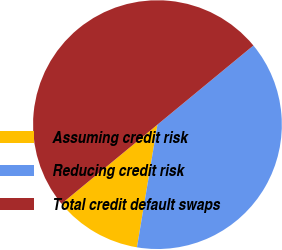Convert chart. <chart><loc_0><loc_0><loc_500><loc_500><pie_chart><fcel>Assuming credit risk<fcel>Reducing credit risk<fcel>Total credit default swaps<nl><fcel>11.39%<fcel>38.61%<fcel>50.0%<nl></chart> 